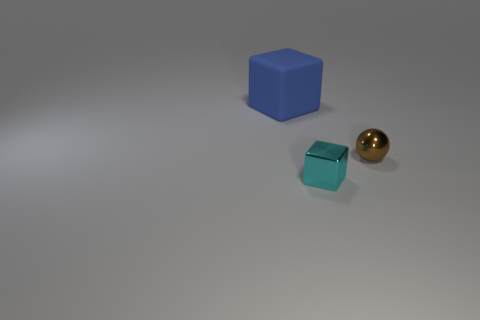The small thing that is in front of the tiny metal thing that is behind the cyan block is made of what material?
Give a very brief answer. Metal. There is a thing that is behind the thing that is right of the cube on the right side of the large blue matte cube; how big is it?
Ensure brevity in your answer.  Large. Do the large blue thing and the small metallic object in front of the tiny brown metal thing have the same shape?
Offer a terse response. Yes. What is the material of the big blue object?
Offer a very short reply. Rubber. What number of rubber objects are either tiny yellow balls or small cyan blocks?
Offer a terse response. 0. Are there fewer small brown balls in front of the tiny cyan object than small cyan cubes that are in front of the large object?
Your answer should be very brief. Yes. Is there a small cyan block in front of the object to the left of the block right of the large blue cube?
Your answer should be very brief. Yes. Do the metal thing left of the tiny brown shiny sphere and the object behind the brown shiny thing have the same shape?
Your response must be concise. Yes. There is a object that is the same size as the ball; what material is it?
Provide a succinct answer. Metal. Do the thing on the right side of the small cyan metallic cube and the block to the right of the blue block have the same material?
Your answer should be very brief. Yes. 